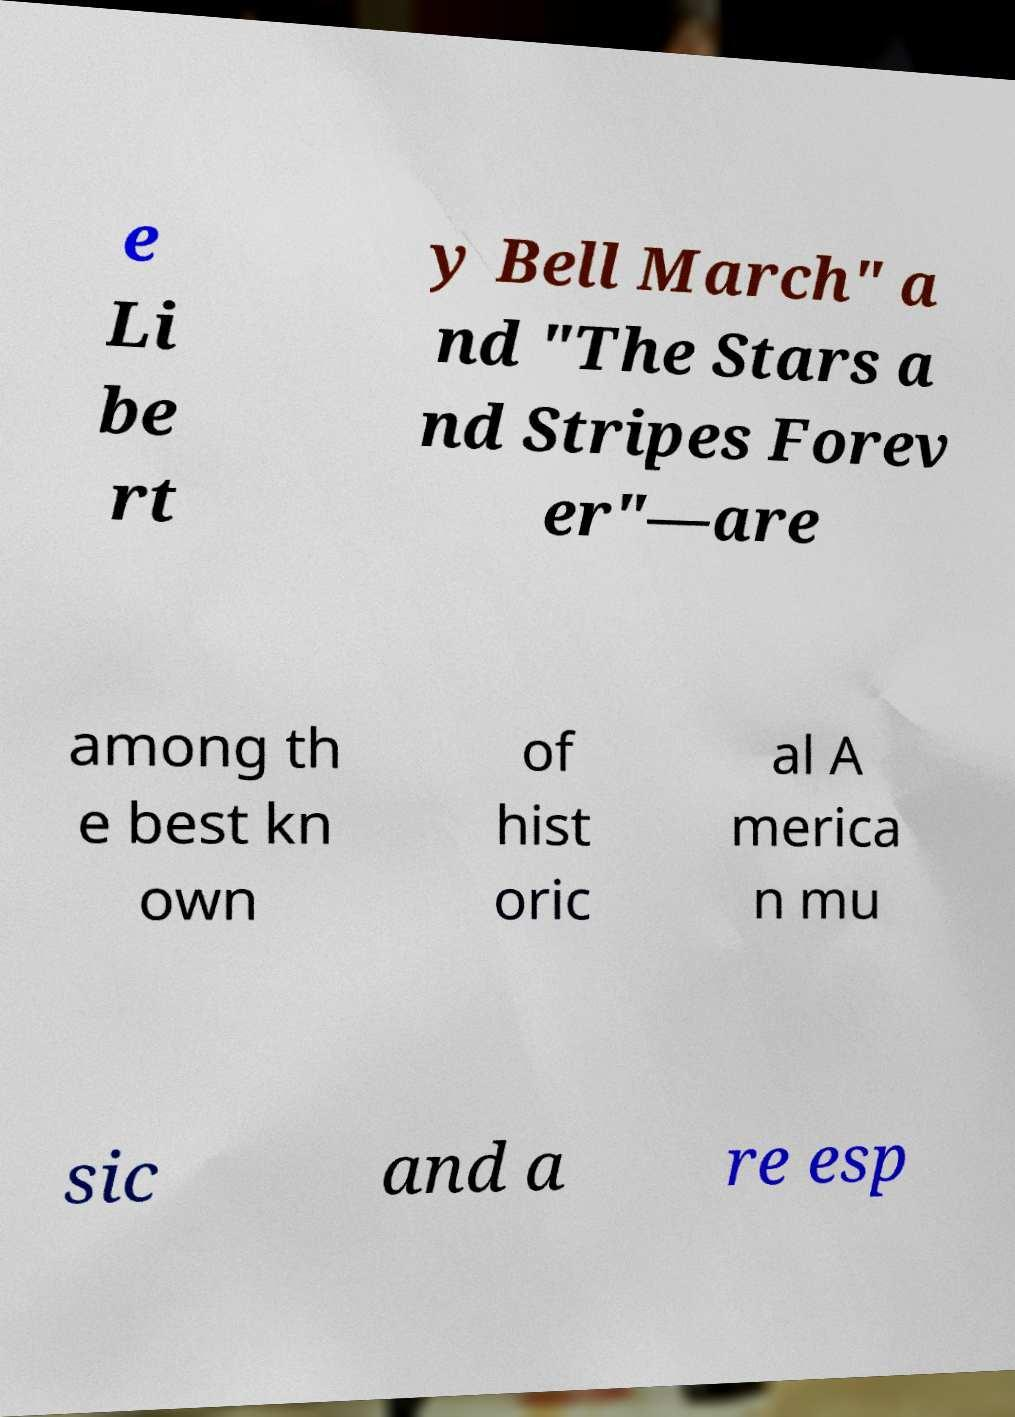Please read and relay the text visible in this image. What does it say? e Li be rt y Bell March" a nd "The Stars a nd Stripes Forev er"—are among th e best kn own of hist oric al A merica n mu sic and a re esp 